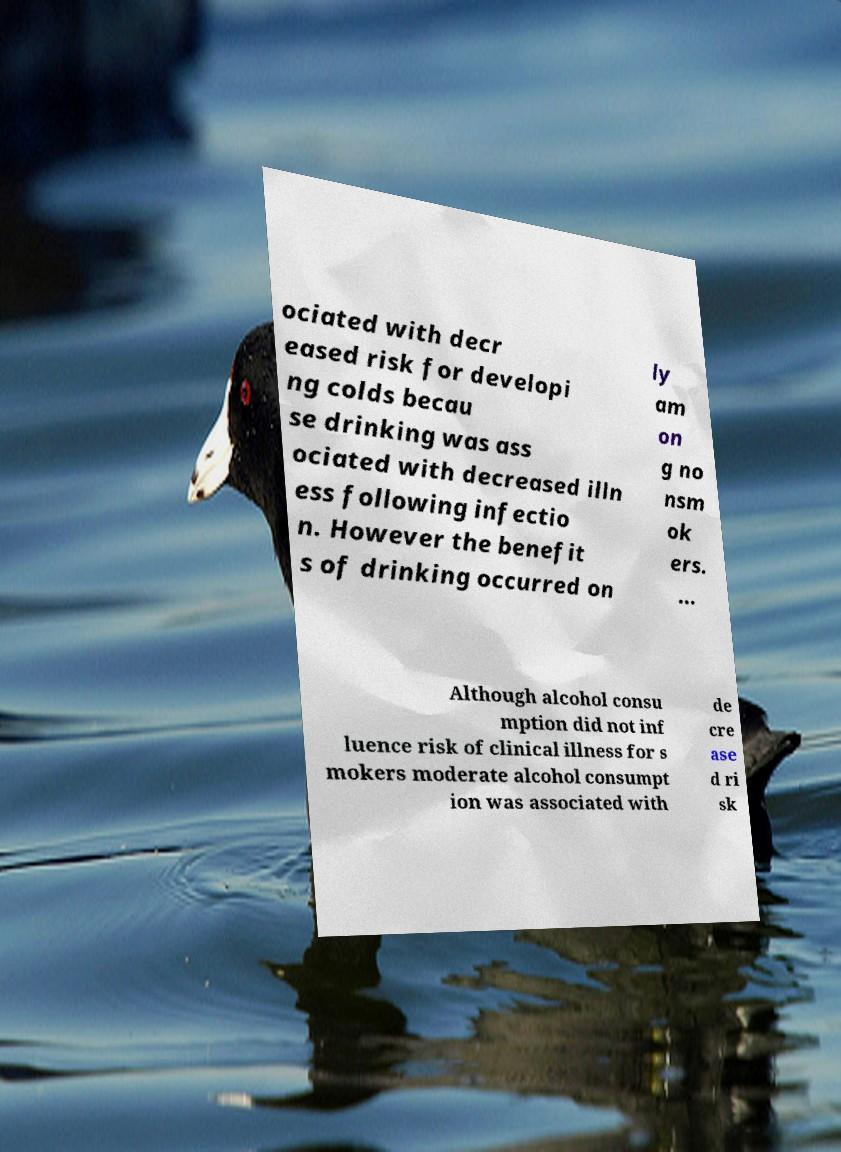Can you accurately transcribe the text from the provided image for me? ociated with decr eased risk for developi ng colds becau se drinking was ass ociated with decreased illn ess following infectio n. However the benefit s of drinking occurred on ly am on g no nsm ok ers. ... Although alcohol consu mption did not inf luence risk of clinical illness for s mokers moderate alcohol consumpt ion was associated with de cre ase d ri sk 